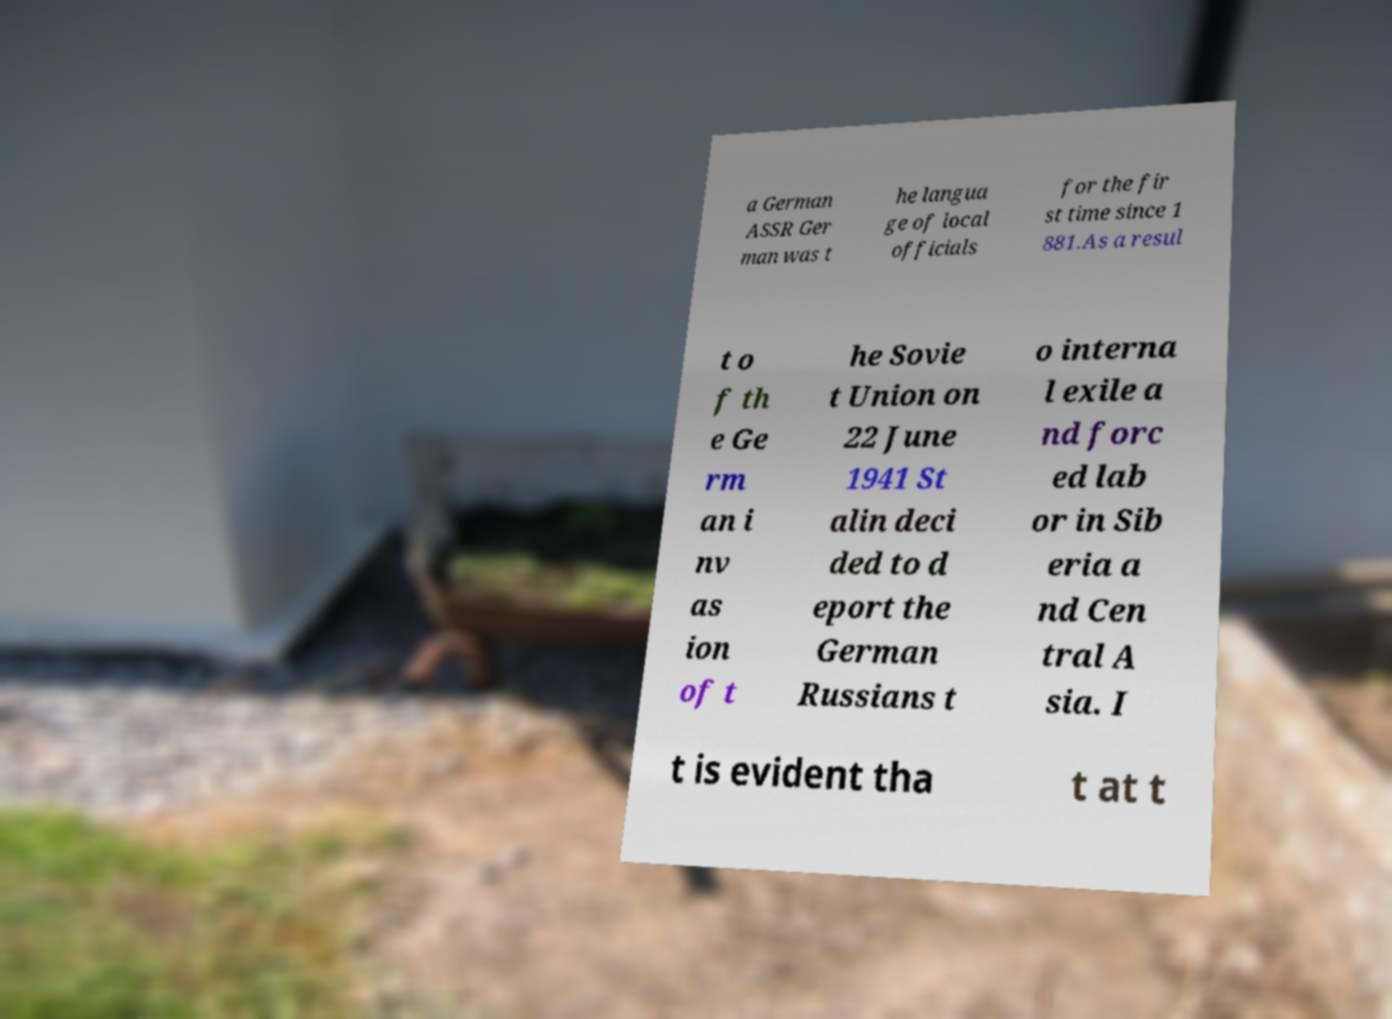Please read and relay the text visible in this image. What does it say? a German ASSR Ger man was t he langua ge of local officials for the fir st time since 1 881.As a resul t o f th e Ge rm an i nv as ion of t he Sovie t Union on 22 June 1941 St alin deci ded to d eport the German Russians t o interna l exile a nd forc ed lab or in Sib eria a nd Cen tral A sia. I t is evident tha t at t 